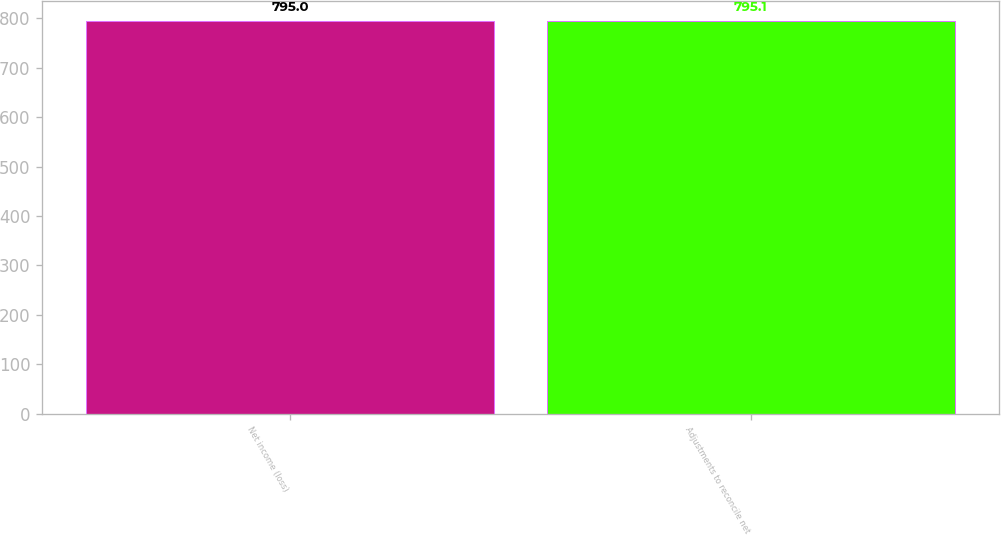<chart> <loc_0><loc_0><loc_500><loc_500><bar_chart><fcel>Net income (loss)<fcel>Adjustments to reconcile net<nl><fcel>795<fcel>795.1<nl></chart> 